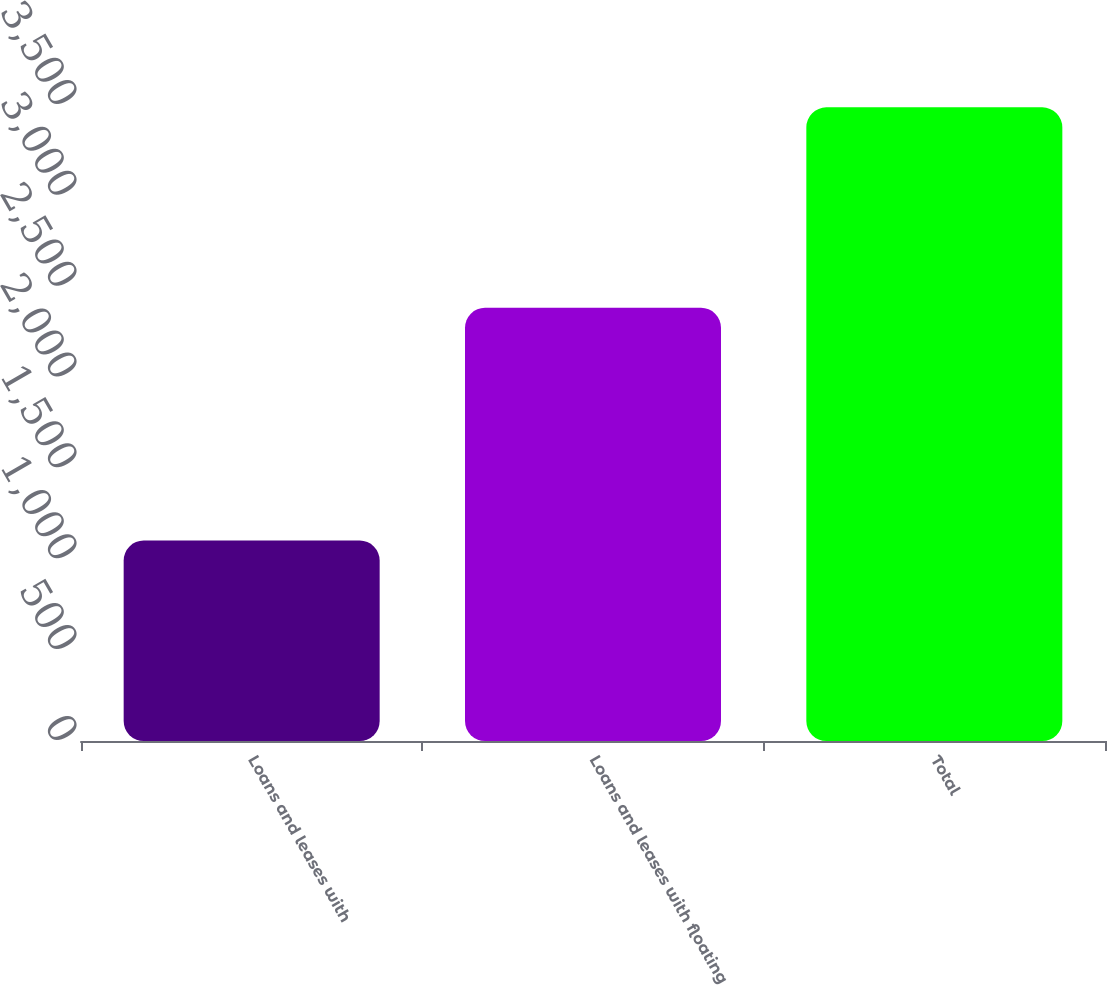<chart> <loc_0><loc_0><loc_500><loc_500><bar_chart><fcel>Loans and leases with<fcel>Loans and leases with floating<fcel>Total<nl><fcel>1103<fcel>2384<fcel>3487<nl></chart> 